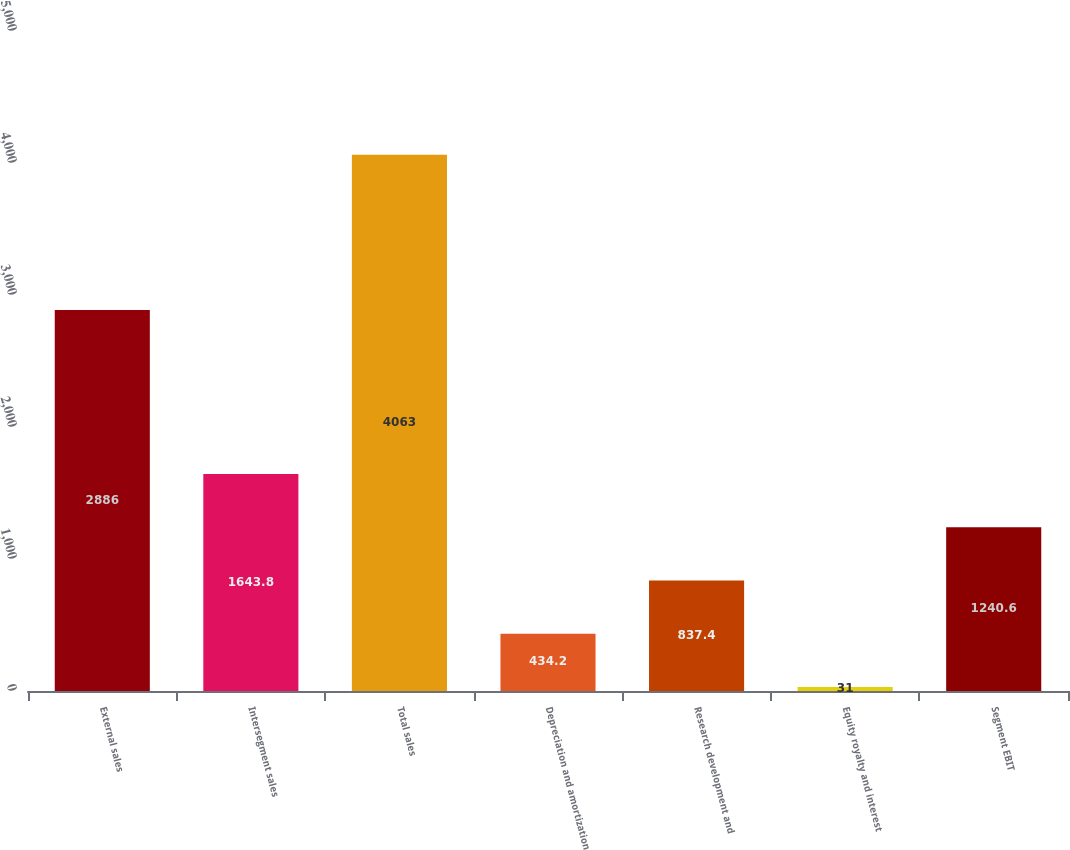<chart> <loc_0><loc_0><loc_500><loc_500><bar_chart><fcel>External sales<fcel>Intersegment sales<fcel>Total sales<fcel>Depreciation and amortization<fcel>Research development and<fcel>Equity royalty and interest<fcel>Segment EBIT<nl><fcel>2886<fcel>1643.8<fcel>4063<fcel>434.2<fcel>837.4<fcel>31<fcel>1240.6<nl></chart> 